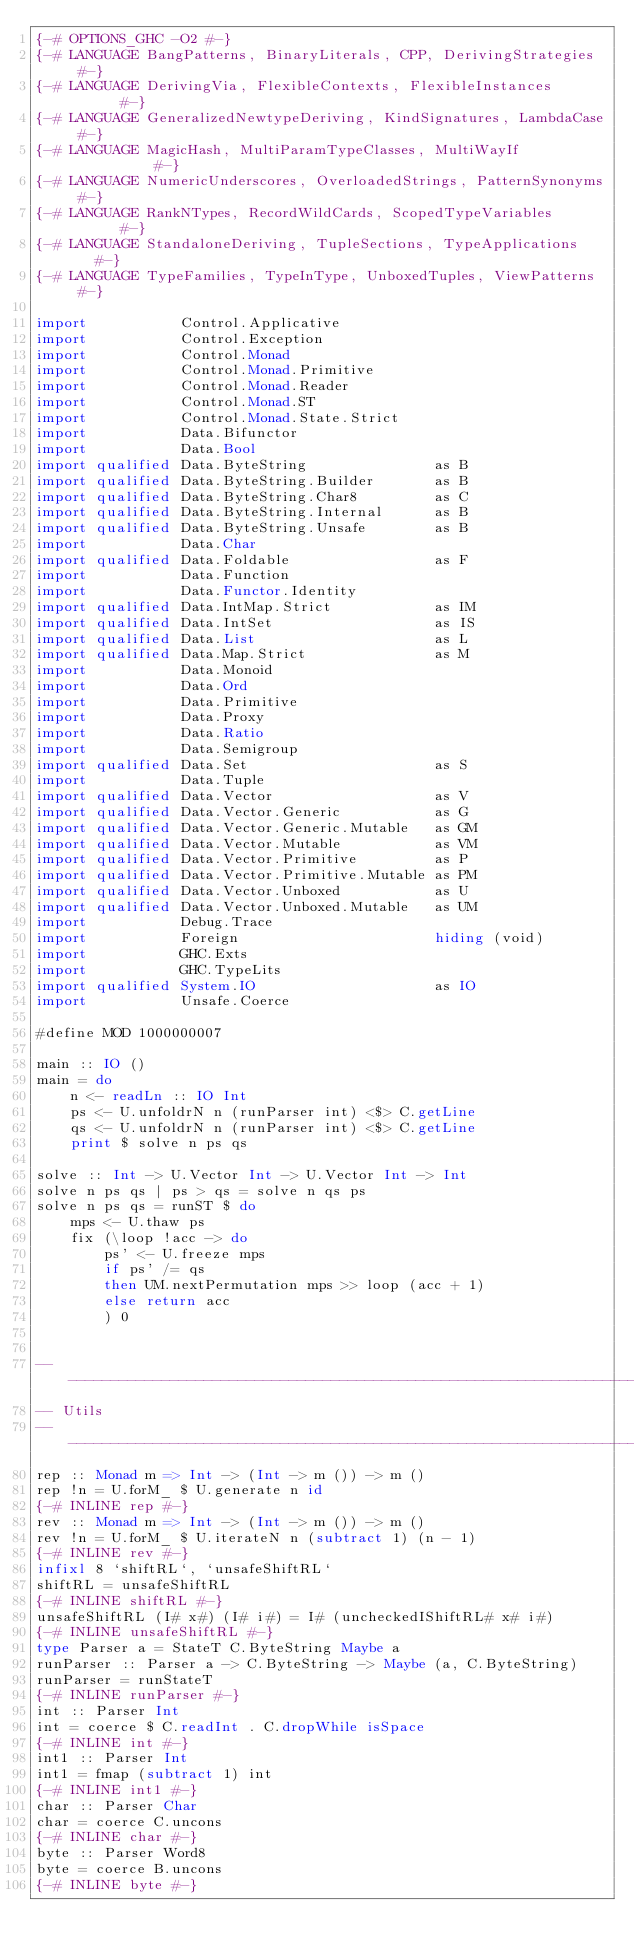Convert code to text. <code><loc_0><loc_0><loc_500><loc_500><_Haskell_>{-# OPTIONS_GHC -O2 #-}
{-# LANGUAGE BangPatterns, BinaryLiterals, CPP, DerivingStrategies  #-}
{-# LANGUAGE DerivingVia, FlexibleContexts, FlexibleInstances       #-}
{-# LANGUAGE GeneralizedNewtypeDeriving, KindSignatures, LambdaCase #-}
{-# LANGUAGE MagicHash, MultiParamTypeClasses, MultiWayIf           #-}
{-# LANGUAGE NumericUnderscores, OverloadedStrings, PatternSynonyms #-}
{-# LANGUAGE RankNTypes, RecordWildCards, ScopedTypeVariables       #-}
{-# LANGUAGE StandaloneDeriving, TupleSections, TypeApplications    #-}
{-# LANGUAGE TypeFamilies, TypeInType, UnboxedTuples, ViewPatterns  #-}

import           Control.Applicative
import           Control.Exception
import           Control.Monad
import           Control.Monad.Primitive
import           Control.Monad.Reader
import           Control.Monad.ST
import           Control.Monad.State.Strict
import           Data.Bifunctor
import           Data.Bool
import qualified Data.ByteString               as B
import qualified Data.ByteString.Builder       as B
import qualified Data.ByteString.Char8         as C
import qualified Data.ByteString.Internal      as B
import qualified Data.ByteString.Unsafe        as B
import           Data.Char
import qualified Data.Foldable                 as F
import           Data.Function
import           Data.Functor.Identity
import qualified Data.IntMap.Strict            as IM
import qualified Data.IntSet                   as IS
import qualified Data.List                     as L
import qualified Data.Map.Strict               as M
import           Data.Monoid
import           Data.Ord
import           Data.Primitive
import           Data.Proxy
import           Data.Ratio
import           Data.Semigroup
import qualified Data.Set                      as S
import           Data.Tuple
import qualified Data.Vector                   as V
import qualified Data.Vector.Generic           as G
import qualified Data.Vector.Generic.Mutable   as GM
import qualified Data.Vector.Mutable           as VM
import qualified Data.Vector.Primitive         as P
import qualified Data.Vector.Primitive.Mutable as PM
import qualified Data.Vector.Unboxed           as U
import qualified Data.Vector.Unboxed.Mutable   as UM
import           Debug.Trace
import           Foreign                       hiding (void)
import           GHC.Exts
import           GHC.TypeLits
import qualified System.IO                     as IO
import           Unsafe.Coerce

#define MOD 1000000007

main :: IO ()
main = do
    n <- readLn :: IO Int
    ps <- U.unfoldrN n (runParser int) <$> C.getLine
    qs <- U.unfoldrN n (runParser int) <$> C.getLine
    print $ solve n ps qs

solve :: Int -> U.Vector Int -> U.Vector Int -> Int
solve n ps qs | ps > qs = solve n qs ps
solve n ps qs = runST $ do
    mps <- U.thaw ps
    fix (\loop !acc -> do
        ps' <- U.freeze mps
        if ps' /= qs
        then UM.nextPermutation mps >> loop (acc + 1)
        else return acc
        ) 0


-------------------------------------------------------------------------------
-- Utils
-------------------------------------------------------------------------------
rep :: Monad m => Int -> (Int -> m ()) -> m ()
rep !n = U.forM_ $ U.generate n id
{-# INLINE rep #-}
rev :: Monad m => Int -> (Int -> m ()) -> m ()
rev !n = U.forM_ $ U.iterateN n (subtract 1) (n - 1)
{-# INLINE rev #-}
infixl 8 `shiftRL`, `unsafeShiftRL`
shiftRL = unsafeShiftRL
{-# INLINE shiftRL #-}
unsafeShiftRL (I# x#) (I# i#) = I# (uncheckedIShiftRL# x# i#)
{-# INLINE unsafeShiftRL #-}
type Parser a = StateT C.ByteString Maybe a
runParser :: Parser a -> C.ByteString -> Maybe (a, C.ByteString)
runParser = runStateT
{-# INLINE runParser #-}
int :: Parser Int
int = coerce $ C.readInt . C.dropWhile isSpace
{-# INLINE int #-}
int1 :: Parser Int
int1 = fmap (subtract 1) int
{-# INLINE int1 #-}
char :: Parser Char
char = coerce C.uncons
{-# INLINE char #-}
byte :: Parser Word8
byte = coerce B.uncons
{-# INLINE byte #-}
</code> 